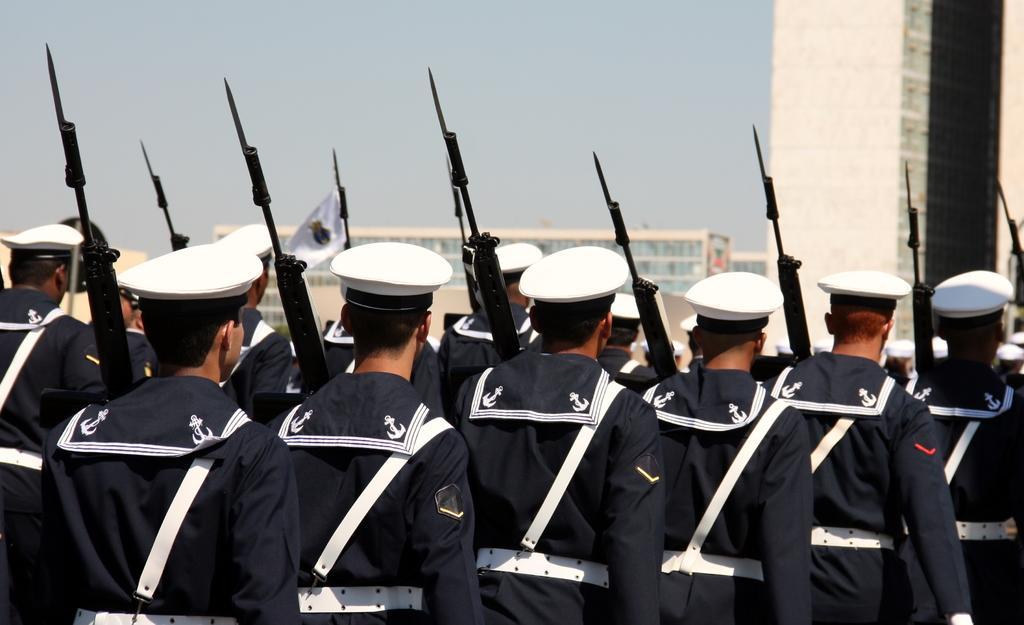Can you describe this image briefly? In this image we can see people. They are wearing uniforms and we can see rifles. In the background there are buildings and sky. 